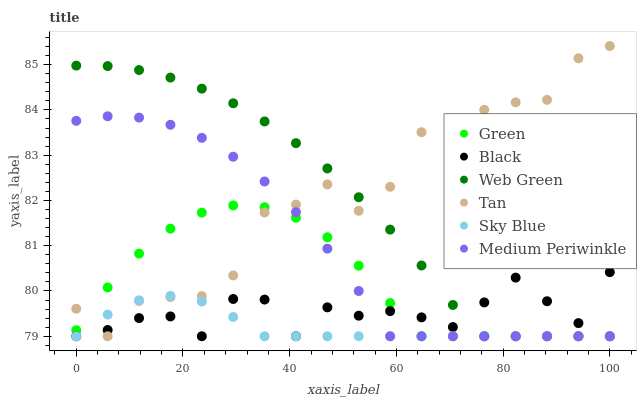Does Sky Blue have the minimum area under the curve?
Answer yes or no. Yes. Does Tan have the maximum area under the curve?
Answer yes or no. Yes. Does Web Green have the minimum area under the curve?
Answer yes or no. No. Does Web Green have the maximum area under the curve?
Answer yes or no. No. Is Sky Blue the smoothest?
Answer yes or no. Yes. Is Tan the roughest?
Answer yes or no. Yes. Is Web Green the smoothest?
Answer yes or no. No. Is Web Green the roughest?
Answer yes or no. No. Does Medium Periwinkle have the lowest value?
Answer yes or no. Yes. Does Tan have the highest value?
Answer yes or no. Yes. Does Web Green have the highest value?
Answer yes or no. No. Does Sky Blue intersect Medium Periwinkle?
Answer yes or no. Yes. Is Sky Blue less than Medium Periwinkle?
Answer yes or no. No. Is Sky Blue greater than Medium Periwinkle?
Answer yes or no. No. 